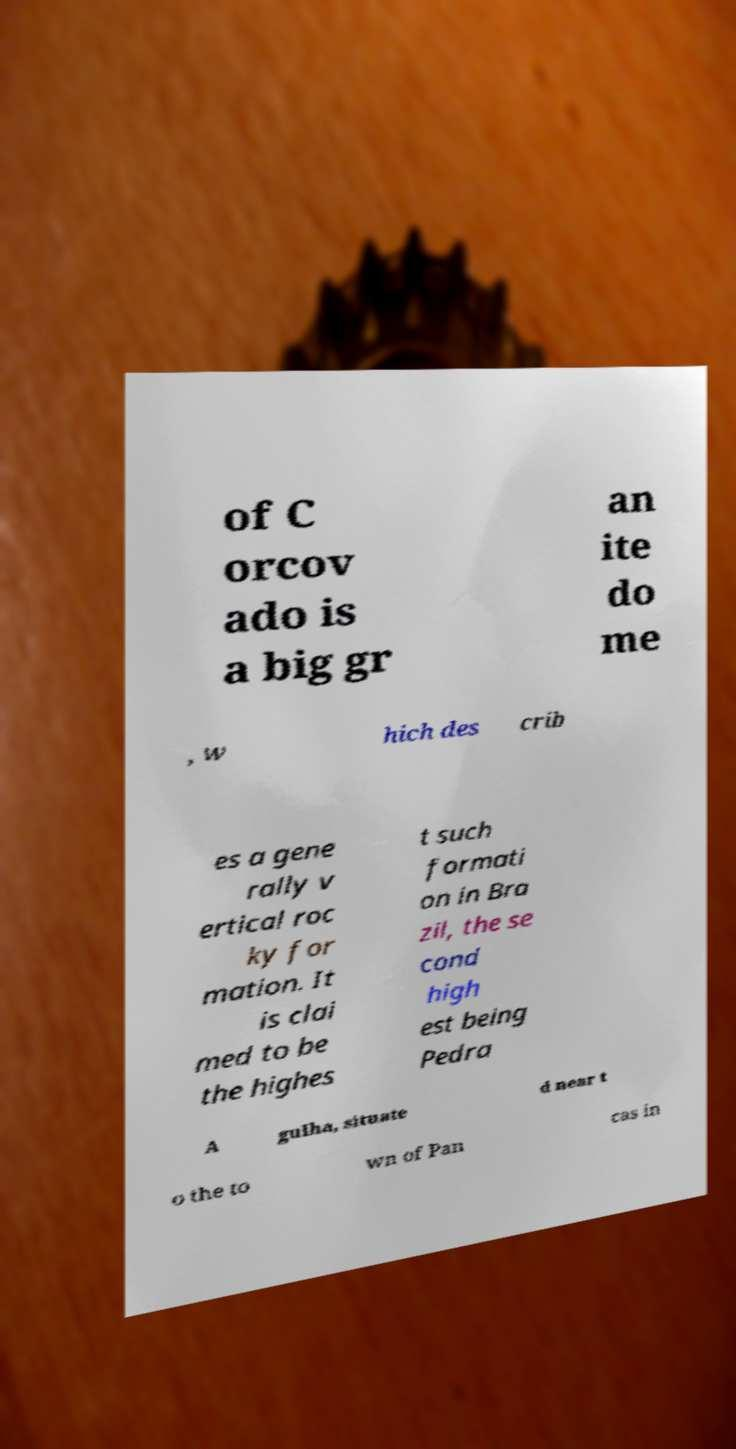Could you assist in decoding the text presented in this image and type it out clearly? of C orcov ado is a big gr an ite do me , w hich des crib es a gene rally v ertical roc ky for mation. It is clai med to be the highes t such formati on in Bra zil, the se cond high est being Pedra A gulha, situate d near t o the to wn of Pan cas in 